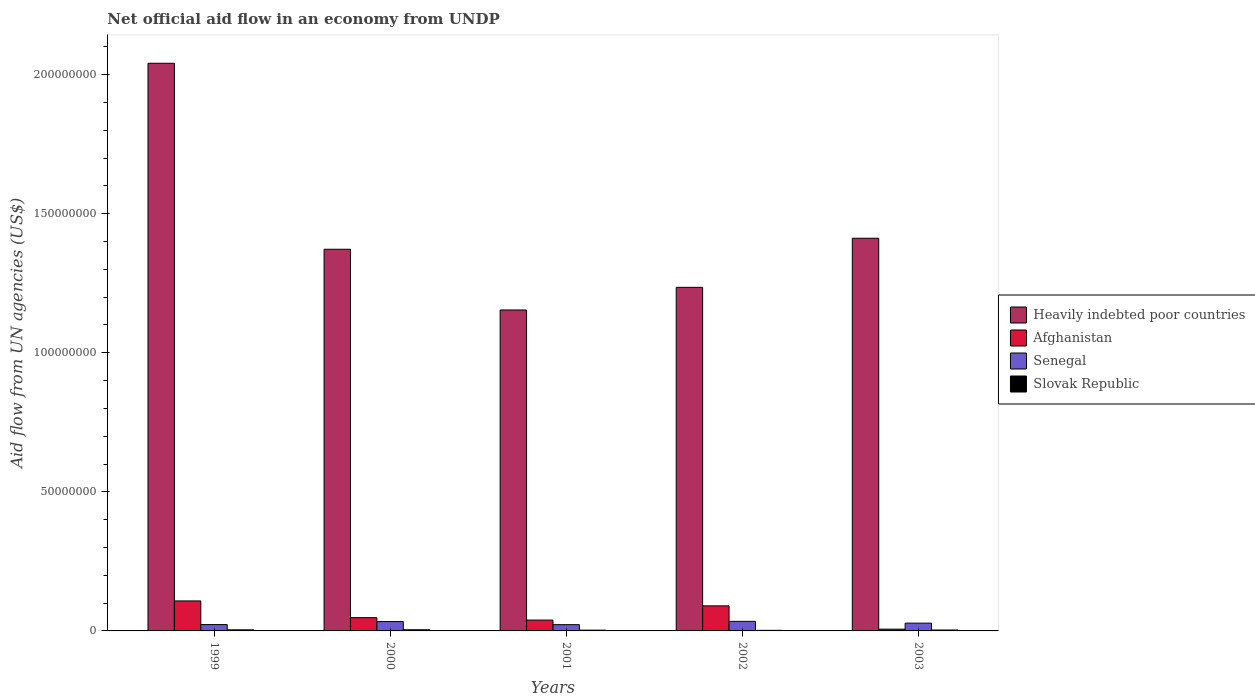Are the number of bars on each tick of the X-axis equal?
Your response must be concise. Yes. How many bars are there on the 4th tick from the left?
Your response must be concise. 4. What is the label of the 4th group of bars from the left?
Ensure brevity in your answer.  2002. What is the net official aid flow in Afghanistan in 2001?
Ensure brevity in your answer.  3.90e+06. Across all years, what is the maximum net official aid flow in Senegal?
Your response must be concise. 3.44e+06. Across all years, what is the minimum net official aid flow in Slovak Republic?
Your response must be concise. 2.10e+05. In which year was the net official aid flow in Slovak Republic maximum?
Provide a short and direct response. 2000. What is the total net official aid flow in Senegal in the graph?
Give a very brief answer. 1.41e+07. What is the difference between the net official aid flow in Heavily indebted poor countries in 1999 and that in 2002?
Your response must be concise. 8.06e+07. What is the difference between the net official aid flow in Slovak Republic in 2000 and the net official aid flow in Senegal in 2002?
Your response must be concise. -3.03e+06. What is the average net official aid flow in Slovak Republic per year?
Provide a short and direct response. 3.24e+05. In the year 2002, what is the difference between the net official aid flow in Slovak Republic and net official aid flow in Afghanistan?
Make the answer very short. -8.80e+06. In how many years, is the net official aid flow in Slovak Republic greater than 60000000 US$?
Give a very brief answer. 0. What is the ratio of the net official aid flow in Heavily indebted poor countries in 2000 to that in 2002?
Your answer should be very brief. 1.11. Is the difference between the net official aid flow in Slovak Republic in 2000 and 2003 greater than the difference between the net official aid flow in Afghanistan in 2000 and 2003?
Provide a succinct answer. No. What is the difference between the highest and the second highest net official aid flow in Afghanistan?
Keep it short and to the point. 1.77e+06. What is the difference between the highest and the lowest net official aid flow in Senegal?
Provide a short and direct response. 1.19e+06. Is it the case that in every year, the sum of the net official aid flow in Slovak Republic and net official aid flow in Afghanistan is greater than the sum of net official aid flow in Senegal and net official aid flow in Heavily indebted poor countries?
Keep it short and to the point. No. What does the 4th bar from the left in 2001 represents?
Keep it short and to the point. Slovak Republic. What does the 1st bar from the right in 2003 represents?
Make the answer very short. Slovak Republic. Is it the case that in every year, the sum of the net official aid flow in Senegal and net official aid flow in Slovak Republic is greater than the net official aid flow in Heavily indebted poor countries?
Your answer should be very brief. No. Are all the bars in the graph horizontal?
Give a very brief answer. No. How many years are there in the graph?
Provide a succinct answer. 5. What is the difference between two consecutive major ticks on the Y-axis?
Provide a succinct answer. 5.00e+07. Are the values on the major ticks of Y-axis written in scientific E-notation?
Your response must be concise. No. Does the graph contain any zero values?
Give a very brief answer. No. Does the graph contain grids?
Ensure brevity in your answer.  No. How many legend labels are there?
Offer a very short reply. 4. How are the legend labels stacked?
Give a very brief answer. Vertical. What is the title of the graph?
Offer a terse response. Net official aid flow in an economy from UNDP. What is the label or title of the X-axis?
Your answer should be very brief. Years. What is the label or title of the Y-axis?
Your answer should be compact. Aid flow from UN agencies (US$). What is the Aid flow from UN agencies (US$) of Heavily indebted poor countries in 1999?
Offer a terse response. 2.04e+08. What is the Aid flow from UN agencies (US$) in Afghanistan in 1999?
Your answer should be compact. 1.08e+07. What is the Aid flow from UN agencies (US$) of Senegal in 1999?
Offer a very short reply. 2.28e+06. What is the Aid flow from UN agencies (US$) in Heavily indebted poor countries in 2000?
Provide a short and direct response. 1.37e+08. What is the Aid flow from UN agencies (US$) in Afghanistan in 2000?
Give a very brief answer. 4.77e+06. What is the Aid flow from UN agencies (US$) in Senegal in 2000?
Offer a very short reply. 3.37e+06. What is the Aid flow from UN agencies (US$) in Slovak Republic in 2000?
Offer a very short reply. 4.10e+05. What is the Aid flow from UN agencies (US$) of Heavily indebted poor countries in 2001?
Your response must be concise. 1.15e+08. What is the Aid flow from UN agencies (US$) of Afghanistan in 2001?
Provide a short and direct response. 3.90e+06. What is the Aid flow from UN agencies (US$) in Senegal in 2001?
Provide a succinct answer. 2.25e+06. What is the Aid flow from UN agencies (US$) in Heavily indebted poor countries in 2002?
Your answer should be very brief. 1.24e+08. What is the Aid flow from UN agencies (US$) in Afghanistan in 2002?
Keep it short and to the point. 9.01e+06. What is the Aid flow from UN agencies (US$) in Senegal in 2002?
Give a very brief answer. 3.44e+06. What is the Aid flow from UN agencies (US$) in Slovak Republic in 2002?
Your answer should be very brief. 2.10e+05. What is the Aid flow from UN agencies (US$) in Heavily indebted poor countries in 2003?
Provide a short and direct response. 1.41e+08. What is the Aid flow from UN agencies (US$) in Afghanistan in 2003?
Offer a terse response. 6.40e+05. What is the Aid flow from UN agencies (US$) in Senegal in 2003?
Give a very brief answer. 2.80e+06. What is the Aid flow from UN agencies (US$) of Slovak Republic in 2003?
Provide a succinct answer. 3.30e+05. Across all years, what is the maximum Aid flow from UN agencies (US$) of Heavily indebted poor countries?
Ensure brevity in your answer.  2.04e+08. Across all years, what is the maximum Aid flow from UN agencies (US$) of Afghanistan?
Give a very brief answer. 1.08e+07. Across all years, what is the maximum Aid flow from UN agencies (US$) in Senegal?
Your answer should be compact. 3.44e+06. Across all years, what is the minimum Aid flow from UN agencies (US$) of Heavily indebted poor countries?
Make the answer very short. 1.15e+08. Across all years, what is the minimum Aid flow from UN agencies (US$) in Afghanistan?
Offer a terse response. 6.40e+05. Across all years, what is the minimum Aid flow from UN agencies (US$) in Senegal?
Make the answer very short. 2.25e+06. What is the total Aid flow from UN agencies (US$) in Heavily indebted poor countries in the graph?
Provide a succinct answer. 7.21e+08. What is the total Aid flow from UN agencies (US$) of Afghanistan in the graph?
Ensure brevity in your answer.  2.91e+07. What is the total Aid flow from UN agencies (US$) in Senegal in the graph?
Your answer should be compact. 1.41e+07. What is the total Aid flow from UN agencies (US$) in Slovak Republic in the graph?
Provide a short and direct response. 1.62e+06. What is the difference between the Aid flow from UN agencies (US$) of Heavily indebted poor countries in 1999 and that in 2000?
Make the answer very short. 6.69e+07. What is the difference between the Aid flow from UN agencies (US$) of Afghanistan in 1999 and that in 2000?
Your answer should be very brief. 6.01e+06. What is the difference between the Aid flow from UN agencies (US$) in Senegal in 1999 and that in 2000?
Provide a short and direct response. -1.09e+06. What is the difference between the Aid flow from UN agencies (US$) of Heavily indebted poor countries in 1999 and that in 2001?
Provide a succinct answer. 8.87e+07. What is the difference between the Aid flow from UN agencies (US$) in Afghanistan in 1999 and that in 2001?
Provide a short and direct response. 6.88e+06. What is the difference between the Aid flow from UN agencies (US$) in Senegal in 1999 and that in 2001?
Ensure brevity in your answer.  3.00e+04. What is the difference between the Aid flow from UN agencies (US$) of Slovak Republic in 1999 and that in 2001?
Provide a short and direct response. 1.10e+05. What is the difference between the Aid flow from UN agencies (US$) of Heavily indebted poor countries in 1999 and that in 2002?
Ensure brevity in your answer.  8.06e+07. What is the difference between the Aid flow from UN agencies (US$) of Afghanistan in 1999 and that in 2002?
Provide a succinct answer. 1.77e+06. What is the difference between the Aid flow from UN agencies (US$) of Senegal in 1999 and that in 2002?
Give a very brief answer. -1.16e+06. What is the difference between the Aid flow from UN agencies (US$) in Slovak Republic in 1999 and that in 2002?
Provide a short and direct response. 1.80e+05. What is the difference between the Aid flow from UN agencies (US$) in Heavily indebted poor countries in 1999 and that in 2003?
Offer a very short reply. 6.29e+07. What is the difference between the Aid flow from UN agencies (US$) in Afghanistan in 1999 and that in 2003?
Provide a succinct answer. 1.01e+07. What is the difference between the Aid flow from UN agencies (US$) in Senegal in 1999 and that in 2003?
Give a very brief answer. -5.20e+05. What is the difference between the Aid flow from UN agencies (US$) of Heavily indebted poor countries in 2000 and that in 2001?
Give a very brief answer. 2.18e+07. What is the difference between the Aid flow from UN agencies (US$) in Afghanistan in 2000 and that in 2001?
Your answer should be very brief. 8.70e+05. What is the difference between the Aid flow from UN agencies (US$) in Senegal in 2000 and that in 2001?
Keep it short and to the point. 1.12e+06. What is the difference between the Aid flow from UN agencies (US$) in Heavily indebted poor countries in 2000 and that in 2002?
Keep it short and to the point. 1.37e+07. What is the difference between the Aid flow from UN agencies (US$) of Afghanistan in 2000 and that in 2002?
Offer a terse response. -4.24e+06. What is the difference between the Aid flow from UN agencies (US$) in Slovak Republic in 2000 and that in 2002?
Give a very brief answer. 2.00e+05. What is the difference between the Aid flow from UN agencies (US$) in Heavily indebted poor countries in 2000 and that in 2003?
Ensure brevity in your answer.  -3.96e+06. What is the difference between the Aid flow from UN agencies (US$) of Afghanistan in 2000 and that in 2003?
Your answer should be very brief. 4.13e+06. What is the difference between the Aid flow from UN agencies (US$) of Senegal in 2000 and that in 2003?
Give a very brief answer. 5.70e+05. What is the difference between the Aid flow from UN agencies (US$) of Heavily indebted poor countries in 2001 and that in 2002?
Offer a terse response. -8.14e+06. What is the difference between the Aid flow from UN agencies (US$) in Afghanistan in 2001 and that in 2002?
Keep it short and to the point. -5.11e+06. What is the difference between the Aid flow from UN agencies (US$) of Senegal in 2001 and that in 2002?
Make the answer very short. -1.19e+06. What is the difference between the Aid flow from UN agencies (US$) of Slovak Republic in 2001 and that in 2002?
Give a very brief answer. 7.00e+04. What is the difference between the Aid flow from UN agencies (US$) in Heavily indebted poor countries in 2001 and that in 2003?
Provide a succinct answer. -2.58e+07. What is the difference between the Aid flow from UN agencies (US$) of Afghanistan in 2001 and that in 2003?
Offer a terse response. 3.26e+06. What is the difference between the Aid flow from UN agencies (US$) in Senegal in 2001 and that in 2003?
Ensure brevity in your answer.  -5.50e+05. What is the difference between the Aid flow from UN agencies (US$) of Heavily indebted poor countries in 2002 and that in 2003?
Make the answer very short. -1.76e+07. What is the difference between the Aid flow from UN agencies (US$) in Afghanistan in 2002 and that in 2003?
Offer a terse response. 8.37e+06. What is the difference between the Aid flow from UN agencies (US$) of Senegal in 2002 and that in 2003?
Your answer should be compact. 6.40e+05. What is the difference between the Aid flow from UN agencies (US$) of Slovak Republic in 2002 and that in 2003?
Your answer should be very brief. -1.20e+05. What is the difference between the Aid flow from UN agencies (US$) of Heavily indebted poor countries in 1999 and the Aid flow from UN agencies (US$) of Afghanistan in 2000?
Offer a terse response. 1.99e+08. What is the difference between the Aid flow from UN agencies (US$) of Heavily indebted poor countries in 1999 and the Aid flow from UN agencies (US$) of Senegal in 2000?
Your response must be concise. 2.01e+08. What is the difference between the Aid flow from UN agencies (US$) of Heavily indebted poor countries in 1999 and the Aid flow from UN agencies (US$) of Slovak Republic in 2000?
Your response must be concise. 2.04e+08. What is the difference between the Aid flow from UN agencies (US$) of Afghanistan in 1999 and the Aid flow from UN agencies (US$) of Senegal in 2000?
Provide a short and direct response. 7.41e+06. What is the difference between the Aid flow from UN agencies (US$) of Afghanistan in 1999 and the Aid flow from UN agencies (US$) of Slovak Republic in 2000?
Your response must be concise. 1.04e+07. What is the difference between the Aid flow from UN agencies (US$) of Senegal in 1999 and the Aid flow from UN agencies (US$) of Slovak Republic in 2000?
Provide a short and direct response. 1.87e+06. What is the difference between the Aid flow from UN agencies (US$) in Heavily indebted poor countries in 1999 and the Aid flow from UN agencies (US$) in Afghanistan in 2001?
Give a very brief answer. 2.00e+08. What is the difference between the Aid flow from UN agencies (US$) in Heavily indebted poor countries in 1999 and the Aid flow from UN agencies (US$) in Senegal in 2001?
Offer a terse response. 2.02e+08. What is the difference between the Aid flow from UN agencies (US$) in Heavily indebted poor countries in 1999 and the Aid flow from UN agencies (US$) in Slovak Republic in 2001?
Keep it short and to the point. 2.04e+08. What is the difference between the Aid flow from UN agencies (US$) of Afghanistan in 1999 and the Aid flow from UN agencies (US$) of Senegal in 2001?
Give a very brief answer. 8.53e+06. What is the difference between the Aid flow from UN agencies (US$) of Afghanistan in 1999 and the Aid flow from UN agencies (US$) of Slovak Republic in 2001?
Offer a very short reply. 1.05e+07. What is the difference between the Aid flow from UN agencies (US$) in Heavily indebted poor countries in 1999 and the Aid flow from UN agencies (US$) in Afghanistan in 2002?
Offer a very short reply. 1.95e+08. What is the difference between the Aid flow from UN agencies (US$) of Heavily indebted poor countries in 1999 and the Aid flow from UN agencies (US$) of Senegal in 2002?
Your answer should be compact. 2.01e+08. What is the difference between the Aid flow from UN agencies (US$) in Heavily indebted poor countries in 1999 and the Aid flow from UN agencies (US$) in Slovak Republic in 2002?
Give a very brief answer. 2.04e+08. What is the difference between the Aid flow from UN agencies (US$) in Afghanistan in 1999 and the Aid flow from UN agencies (US$) in Senegal in 2002?
Keep it short and to the point. 7.34e+06. What is the difference between the Aid flow from UN agencies (US$) in Afghanistan in 1999 and the Aid flow from UN agencies (US$) in Slovak Republic in 2002?
Make the answer very short. 1.06e+07. What is the difference between the Aid flow from UN agencies (US$) in Senegal in 1999 and the Aid flow from UN agencies (US$) in Slovak Republic in 2002?
Keep it short and to the point. 2.07e+06. What is the difference between the Aid flow from UN agencies (US$) of Heavily indebted poor countries in 1999 and the Aid flow from UN agencies (US$) of Afghanistan in 2003?
Your answer should be compact. 2.03e+08. What is the difference between the Aid flow from UN agencies (US$) of Heavily indebted poor countries in 1999 and the Aid flow from UN agencies (US$) of Senegal in 2003?
Give a very brief answer. 2.01e+08. What is the difference between the Aid flow from UN agencies (US$) in Heavily indebted poor countries in 1999 and the Aid flow from UN agencies (US$) in Slovak Republic in 2003?
Provide a short and direct response. 2.04e+08. What is the difference between the Aid flow from UN agencies (US$) of Afghanistan in 1999 and the Aid flow from UN agencies (US$) of Senegal in 2003?
Offer a terse response. 7.98e+06. What is the difference between the Aid flow from UN agencies (US$) in Afghanistan in 1999 and the Aid flow from UN agencies (US$) in Slovak Republic in 2003?
Provide a succinct answer. 1.04e+07. What is the difference between the Aid flow from UN agencies (US$) in Senegal in 1999 and the Aid flow from UN agencies (US$) in Slovak Republic in 2003?
Make the answer very short. 1.95e+06. What is the difference between the Aid flow from UN agencies (US$) of Heavily indebted poor countries in 2000 and the Aid flow from UN agencies (US$) of Afghanistan in 2001?
Your answer should be very brief. 1.33e+08. What is the difference between the Aid flow from UN agencies (US$) of Heavily indebted poor countries in 2000 and the Aid flow from UN agencies (US$) of Senegal in 2001?
Keep it short and to the point. 1.35e+08. What is the difference between the Aid flow from UN agencies (US$) of Heavily indebted poor countries in 2000 and the Aid flow from UN agencies (US$) of Slovak Republic in 2001?
Offer a terse response. 1.37e+08. What is the difference between the Aid flow from UN agencies (US$) of Afghanistan in 2000 and the Aid flow from UN agencies (US$) of Senegal in 2001?
Your answer should be compact. 2.52e+06. What is the difference between the Aid flow from UN agencies (US$) of Afghanistan in 2000 and the Aid flow from UN agencies (US$) of Slovak Republic in 2001?
Keep it short and to the point. 4.49e+06. What is the difference between the Aid flow from UN agencies (US$) in Senegal in 2000 and the Aid flow from UN agencies (US$) in Slovak Republic in 2001?
Keep it short and to the point. 3.09e+06. What is the difference between the Aid flow from UN agencies (US$) of Heavily indebted poor countries in 2000 and the Aid flow from UN agencies (US$) of Afghanistan in 2002?
Provide a short and direct response. 1.28e+08. What is the difference between the Aid flow from UN agencies (US$) in Heavily indebted poor countries in 2000 and the Aid flow from UN agencies (US$) in Senegal in 2002?
Your response must be concise. 1.34e+08. What is the difference between the Aid flow from UN agencies (US$) in Heavily indebted poor countries in 2000 and the Aid flow from UN agencies (US$) in Slovak Republic in 2002?
Your response must be concise. 1.37e+08. What is the difference between the Aid flow from UN agencies (US$) of Afghanistan in 2000 and the Aid flow from UN agencies (US$) of Senegal in 2002?
Keep it short and to the point. 1.33e+06. What is the difference between the Aid flow from UN agencies (US$) of Afghanistan in 2000 and the Aid flow from UN agencies (US$) of Slovak Republic in 2002?
Give a very brief answer. 4.56e+06. What is the difference between the Aid flow from UN agencies (US$) in Senegal in 2000 and the Aid flow from UN agencies (US$) in Slovak Republic in 2002?
Ensure brevity in your answer.  3.16e+06. What is the difference between the Aid flow from UN agencies (US$) of Heavily indebted poor countries in 2000 and the Aid flow from UN agencies (US$) of Afghanistan in 2003?
Your answer should be very brief. 1.37e+08. What is the difference between the Aid flow from UN agencies (US$) in Heavily indebted poor countries in 2000 and the Aid flow from UN agencies (US$) in Senegal in 2003?
Provide a short and direct response. 1.34e+08. What is the difference between the Aid flow from UN agencies (US$) in Heavily indebted poor countries in 2000 and the Aid flow from UN agencies (US$) in Slovak Republic in 2003?
Ensure brevity in your answer.  1.37e+08. What is the difference between the Aid flow from UN agencies (US$) of Afghanistan in 2000 and the Aid flow from UN agencies (US$) of Senegal in 2003?
Give a very brief answer. 1.97e+06. What is the difference between the Aid flow from UN agencies (US$) of Afghanistan in 2000 and the Aid flow from UN agencies (US$) of Slovak Republic in 2003?
Ensure brevity in your answer.  4.44e+06. What is the difference between the Aid flow from UN agencies (US$) of Senegal in 2000 and the Aid flow from UN agencies (US$) of Slovak Republic in 2003?
Keep it short and to the point. 3.04e+06. What is the difference between the Aid flow from UN agencies (US$) of Heavily indebted poor countries in 2001 and the Aid flow from UN agencies (US$) of Afghanistan in 2002?
Give a very brief answer. 1.06e+08. What is the difference between the Aid flow from UN agencies (US$) of Heavily indebted poor countries in 2001 and the Aid flow from UN agencies (US$) of Senegal in 2002?
Provide a succinct answer. 1.12e+08. What is the difference between the Aid flow from UN agencies (US$) in Heavily indebted poor countries in 2001 and the Aid flow from UN agencies (US$) in Slovak Republic in 2002?
Keep it short and to the point. 1.15e+08. What is the difference between the Aid flow from UN agencies (US$) in Afghanistan in 2001 and the Aid flow from UN agencies (US$) in Slovak Republic in 2002?
Give a very brief answer. 3.69e+06. What is the difference between the Aid flow from UN agencies (US$) of Senegal in 2001 and the Aid flow from UN agencies (US$) of Slovak Republic in 2002?
Your response must be concise. 2.04e+06. What is the difference between the Aid flow from UN agencies (US$) of Heavily indebted poor countries in 2001 and the Aid flow from UN agencies (US$) of Afghanistan in 2003?
Offer a terse response. 1.15e+08. What is the difference between the Aid flow from UN agencies (US$) of Heavily indebted poor countries in 2001 and the Aid flow from UN agencies (US$) of Senegal in 2003?
Offer a terse response. 1.13e+08. What is the difference between the Aid flow from UN agencies (US$) in Heavily indebted poor countries in 2001 and the Aid flow from UN agencies (US$) in Slovak Republic in 2003?
Make the answer very short. 1.15e+08. What is the difference between the Aid flow from UN agencies (US$) in Afghanistan in 2001 and the Aid flow from UN agencies (US$) in Senegal in 2003?
Provide a succinct answer. 1.10e+06. What is the difference between the Aid flow from UN agencies (US$) of Afghanistan in 2001 and the Aid flow from UN agencies (US$) of Slovak Republic in 2003?
Offer a very short reply. 3.57e+06. What is the difference between the Aid flow from UN agencies (US$) in Senegal in 2001 and the Aid flow from UN agencies (US$) in Slovak Republic in 2003?
Your answer should be compact. 1.92e+06. What is the difference between the Aid flow from UN agencies (US$) in Heavily indebted poor countries in 2002 and the Aid flow from UN agencies (US$) in Afghanistan in 2003?
Provide a succinct answer. 1.23e+08. What is the difference between the Aid flow from UN agencies (US$) in Heavily indebted poor countries in 2002 and the Aid flow from UN agencies (US$) in Senegal in 2003?
Offer a terse response. 1.21e+08. What is the difference between the Aid flow from UN agencies (US$) of Heavily indebted poor countries in 2002 and the Aid flow from UN agencies (US$) of Slovak Republic in 2003?
Provide a succinct answer. 1.23e+08. What is the difference between the Aid flow from UN agencies (US$) of Afghanistan in 2002 and the Aid flow from UN agencies (US$) of Senegal in 2003?
Provide a succinct answer. 6.21e+06. What is the difference between the Aid flow from UN agencies (US$) in Afghanistan in 2002 and the Aid flow from UN agencies (US$) in Slovak Republic in 2003?
Make the answer very short. 8.68e+06. What is the difference between the Aid flow from UN agencies (US$) of Senegal in 2002 and the Aid flow from UN agencies (US$) of Slovak Republic in 2003?
Give a very brief answer. 3.11e+06. What is the average Aid flow from UN agencies (US$) in Heavily indebted poor countries per year?
Offer a terse response. 1.44e+08. What is the average Aid flow from UN agencies (US$) of Afghanistan per year?
Make the answer very short. 5.82e+06. What is the average Aid flow from UN agencies (US$) of Senegal per year?
Offer a terse response. 2.83e+06. What is the average Aid flow from UN agencies (US$) in Slovak Republic per year?
Keep it short and to the point. 3.24e+05. In the year 1999, what is the difference between the Aid flow from UN agencies (US$) of Heavily indebted poor countries and Aid flow from UN agencies (US$) of Afghanistan?
Provide a short and direct response. 1.93e+08. In the year 1999, what is the difference between the Aid flow from UN agencies (US$) of Heavily indebted poor countries and Aid flow from UN agencies (US$) of Senegal?
Offer a very short reply. 2.02e+08. In the year 1999, what is the difference between the Aid flow from UN agencies (US$) in Heavily indebted poor countries and Aid flow from UN agencies (US$) in Slovak Republic?
Your answer should be very brief. 2.04e+08. In the year 1999, what is the difference between the Aid flow from UN agencies (US$) in Afghanistan and Aid flow from UN agencies (US$) in Senegal?
Offer a very short reply. 8.50e+06. In the year 1999, what is the difference between the Aid flow from UN agencies (US$) in Afghanistan and Aid flow from UN agencies (US$) in Slovak Republic?
Give a very brief answer. 1.04e+07. In the year 1999, what is the difference between the Aid flow from UN agencies (US$) of Senegal and Aid flow from UN agencies (US$) of Slovak Republic?
Provide a succinct answer. 1.89e+06. In the year 2000, what is the difference between the Aid flow from UN agencies (US$) in Heavily indebted poor countries and Aid flow from UN agencies (US$) in Afghanistan?
Your response must be concise. 1.32e+08. In the year 2000, what is the difference between the Aid flow from UN agencies (US$) of Heavily indebted poor countries and Aid flow from UN agencies (US$) of Senegal?
Provide a succinct answer. 1.34e+08. In the year 2000, what is the difference between the Aid flow from UN agencies (US$) in Heavily indebted poor countries and Aid flow from UN agencies (US$) in Slovak Republic?
Your answer should be very brief. 1.37e+08. In the year 2000, what is the difference between the Aid flow from UN agencies (US$) in Afghanistan and Aid flow from UN agencies (US$) in Senegal?
Keep it short and to the point. 1.40e+06. In the year 2000, what is the difference between the Aid flow from UN agencies (US$) in Afghanistan and Aid flow from UN agencies (US$) in Slovak Republic?
Your response must be concise. 4.36e+06. In the year 2000, what is the difference between the Aid flow from UN agencies (US$) of Senegal and Aid flow from UN agencies (US$) of Slovak Republic?
Provide a short and direct response. 2.96e+06. In the year 2001, what is the difference between the Aid flow from UN agencies (US$) in Heavily indebted poor countries and Aid flow from UN agencies (US$) in Afghanistan?
Offer a terse response. 1.11e+08. In the year 2001, what is the difference between the Aid flow from UN agencies (US$) of Heavily indebted poor countries and Aid flow from UN agencies (US$) of Senegal?
Your response must be concise. 1.13e+08. In the year 2001, what is the difference between the Aid flow from UN agencies (US$) of Heavily indebted poor countries and Aid flow from UN agencies (US$) of Slovak Republic?
Your answer should be very brief. 1.15e+08. In the year 2001, what is the difference between the Aid flow from UN agencies (US$) in Afghanistan and Aid flow from UN agencies (US$) in Senegal?
Provide a succinct answer. 1.65e+06. In the year 2001, what is the difference between the Aid flow from UN agencies (US$) of Afghanistan and Aid flow from UN agencies (US$) of Slovak Republic?
Offer a very short reply. 3.62e+06. In the year 2001, what is the difference between the Aid flow from UN agencies (US$) of Senegal and Aid flow from UN agencies (US$) of Slovak Republic?
Ensure brevity in your answer.  1.97e+06. In the year 2002, what is the difference between the Aid flow from UN agencies (US$) in Heavily indebted poor countries and Aid flow from UN agencies (US$) in Afghanistan?
Offer a very short reply. 1.15e+08. In the year 2002, what is the difference between the Aid flow from UN agencies (US$) of Heavily indebted poor countries and Aid flow from UN agencies (US$) of Senegal?
Provide a succinct answer. 1.20e+08. In the year 2002, what is the difference between the Aid flow from UN agencies (US$) of Heavily indebted poor countries and Aid flow from UN agencies (US$) of Slovak Republic?
Give a very brief answer. 1.23e+08. In the year 2002, what is the difference between the Aid flow from UN agencies (US$) of Afghanistan and Aid flow from UN agencies (US$) of Senegal?
Provide a short and direct response. 5.57e+06. In the year 2002, what is the difference between the Aid flow from UN agencies (US$) of Afghanistan and Aid flow from UN agencies (US$) of Slovak Republic?
Your answer should be very brief. 8.80e+06. In the year 2002, what is the difference between the Aid flow from UN agencies (US$) in Senegal and Aid flow from UN agencies (US$) in Slovak Republic?
Keep it short and to the point. 3.23e+06. In the year 2003, what is the difference between the Aid flow from UN agencies (US$) of Heavily indebted poor countries and Aid flow from UN agencies (US$) of Afghanistan?
Offer a very short reply. 1.41e+08. In the year 2003, what is the difference between the Aid flow from UN agencies (US$) in Heavily indebted poor countries and Aid flow from UN agencies (US$) in Senegal?
Ensure brevity in your answer.  1.38e+08. In the year 2003, what is the difference between the Aid flow from UN agencies (US$) in Heavily indebted poor countries and Aid flow from UN agencies (US$) in Slovak Republic?
Offer a terse response. 1.41e+08. In the year 2003, what is the difference between the Aid flow from UN agencies (US$) of Afghanistan and Aid flow from UN agencies (US$) of Senegal?
Your answer should be very brief. -2.16e+06. In the year 2003, what is the difference between the Aid flow from UN agencies (US$) in Afghanistan and Aid flow from UN agencies (US$) in Slovak Republic?
Keep it short and to the point. 3.10e+05. In the year 2003, what is the difference between the Aid flow from UN agencies (US$) in Senegal and Aid flow from UN agencies (US$) in Slovak Republic?
Provide a succinct answer. 2.47e+06. What is the ratio of the Aid flow from UN agencies (US$) in Heavily indebted poor countries in 1999 to that in 2000?
Offer a terse response. 1.49. What is the ratio of the Aid flow from UN agencies (US$) in Afghanistan in 1999 to that in 2000?
Give a very brief answer. 2.26. What is the ratio of the Aid flow from UN agencies (US$) in Senegal in 1999 to that in 2000?
Your answer should be compact. 0.68. What is the ratio of the Aid flow from UN agencies (US$) in Slovak Republic in 1999 to that in 2000?
Your answer should be very brief. 0.95. What is the ratio of the Aid flow from UN agencies (US$) of Heavily indebted poor countries in 1999 to that in 2001?
Make the answer very short. 1.77. What is the ratio of the Aid flow from UN agencies (US$) of Afghanistan in 1999 to that in 2001?
Keep it short and to the point. 2.76. What is the ratio of the Aid flow from UN agencies (US$) in Senegal in 1999 to that in 2001?
Make the answer very short. 1.01. What is the ratio of the Aid flow from UN agencies (US$) of Slovak Republic in 1999 to that in 2001?
Make the answer very short. 1.39. What is the ratio of the Aid flow from UN agencies (US$) of Heavily indebted poor countries in 1999 to that in 2002?
Offer a very short reply. 1.65. What is the ratio of the Aid flow from UN agencies (US$) in Afghanistan in 1999 to that in 2002?
Your answer should be very brief. 1.2. What is the ratio of the Aid flow from UN agencies (US$) of Senegal in 1999 to that in 2002?
Keep it short and to the point. 0.66. What is the ratio of the Aid flow from UN agencies (US$) of Slovak Republic in 1999 to that in 2002?
Make the answer very short. 1.86. What is the ratio of the Aid flow from UN agencies (US$) in Heavily indebted poor countries in 1999 to that in 2003?
Provide a succinct answer. 1.45. What is the ratio of the Aid flow from UN agencies (US$) of Afghanistan in 1999 to that in 2003?
Make the answer very short. 16.84. What is the ratio of the Aid flow from UN agencies (US$) of Senegal in 1999 to that in 2003?
Provide a short and direct response. 0.81. What is the ratio of the Aid flow from UN agencies (US$) in Slovak Republic in 1999 to that in 2003?
Your answer should be very brief. 1.18. What is the ratio of the Aid flow from UN agencies (US$) in Heavily indebted poor countries in 2000 to that in 2001?
Offer a terse response. 1.19. What is the ratio of the Aid flow from UN agencies (US$) of Afghanistan in 2000 to that in 2001?
Ensure brevity in your answer.  1.22. What is the ratio of the Aid flow from UN agencies (US$) of Senegal in 2000 to that in 2001?
Keep it short and to the point. 1.5. What is the ratio of the Aid flow from UN agencies (US$) in Slovak Republic in 2000 to that in 2001?
Your response must be concise. 1.46. What is the ratio of the Aid flow from UN agencies (US$) in Heavily indebted poor countries in 2000 to that in 2002?
Ensure brevity in your answer.  1.11. What is the ratio of the Aid flow from UN agencies (US$) in Afghanistan in 2000 to that in 2002?
Your answer should be very brief. 0.53. What is the ratio of the Aid flow from UN agencies (US$) of Senegal in 2000 to that in 2002?
Provide a succinct answer. 0.98. What is the ratio of the Aid flow from UN agencies (US$) in Slovak Republic in 2000 to that in 2002?
Keep it short and to the point. 1.95. What is the ratio of the Aid flow from UN agencies (US$) of Heavily indebted poor countries in 2000 to that in 2003?
Offer a terse response. 0.97. What is the ratio of the Aid flow from UN agencies (US$) of Afghanistan in 2000 to that in 2003?
Your answer should be compact. 7.45. What is the ratio of the Aid flow from UN agencies (US$) in Senegal in 2000 to that in 2003?
Your answer should be compact. 1.2. What is the ratio of the Aid flow from UN agencies (US$) in Slovak Republic in 2000 to that in 2003?
Keep it short and to the point. 1.24. What is the ratio of the Aid flow from UN agencies (US$) of Heavily indebted poor countries in 2001 to that in 2002?
Ensure brevity in your answer.  0.93. What is the ratio of the Aid flow from UN agencies (US$) in Afghanistan in 2001 to that in 2002?
Your response must be concise. 0.43. What is the ratio of the Aid flow from UN agencies (US$) in Senegal in 2001 to that in 2002?
Provide a short and direct response. 0.65. What is the ratio of the Aid flow from UN agencies (US$) of Slovak Republic in 2001 to that in 2002?
Offer a very short reply. 1.33. What is the ratio of the Aid flow from UN agencies (US$) of Heavily indebted poor countries in 2001 to that in 2003?
Offer a terse response. 0.82. What is the ratio of the Aid flow from UN agencies (US$) in Afghanistan in 2001 to that in 2003?
Your answer should be very brief. 6.09. What is the ratio of the Aid flow from UN agencies (US$) of Senegal in 2001 to that in 2003?
Offer a very short reply. 0.8. What is the ratio of the Aid flow from UN agencies (US$) in Slovak Republic in 2001 to that in 2003?
Ensure brevity in your answer.  0.85. What is the ratio of the Aid flow from UN agencies (US$) in Heavily indebted poor countries in 2002 to that in 2003?
Your answer should be compact. 0.88. What is the ratio of the Aid flow from UN agencies (US$) in Afghanistan in 2002 to that in 2003?
Ensure brevity in your answer.  14.08. What is the ratio of the Aid flow from UN agencies (US$) of Senegal in 2002 to that in 2003?
Ensure brevity in your answer.  1.23. What is the ratio of the Aid flow from UN agencies (US$) of Slovak Republic in 2002 to that in 2003?
Give a very brief answer. 0.64. What is the difference between the highest and the second highest Aid flow from UN agencies (US$) of Heavily indebted poor countries?
Provide a short and direct response. 6.29e+07. What is the difference between the highest and the second highest Aid flow from UN agencies (US$) in Afghanistan?
Offer a terse response. 1.77e+06. What is the difference between the highest and the lowest Aid flow from UN agencies (US$) of Heavily indebted poor countries?
Provide a succinct answer. 8.87e+07. What is the difference between the highest and the lowest Aid flow from UN agencies (US$) in Afghanistan?
Provide a short and direct response. 1.01e+07. What is the difference between the highest and the lowest Aid flow from UN agencies (US$) in Senegal?
Keep it short and to the point. 1.19e+06. 